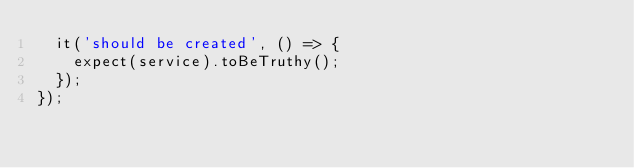Convert code to text. <code><loc_0><loc_0><loc_500><loc_500><_TypeScript_>  it('should be created', () => {
    expect(service).toBeTruthy();
  });
});
</code> 